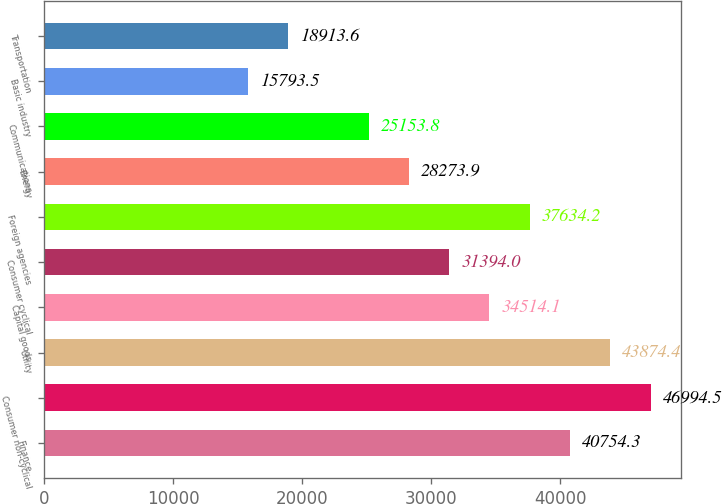Convert chart to OTSL. <chart><loc_0><loc_0><loc_500><loc_500><bar_chart><fcel>Finance<fcel>Consumer non-cyclical<fcel>Utility<fcel>Capital goods<fcel>Consumer cyclical<fcel>Foreign agencies<fcel>Energy<fcel>Communications<fcel>Basic industry<fcel>Transportation<nl><fcel>40754.3<fcel>46994.5<fcel>43874.4<fcel>34514.1<fcel>31394<fcel>37634.2<fcel>28273.9<fcel>25153.8<fcel>15793.5<fcel>18913.6<nl></chart> 